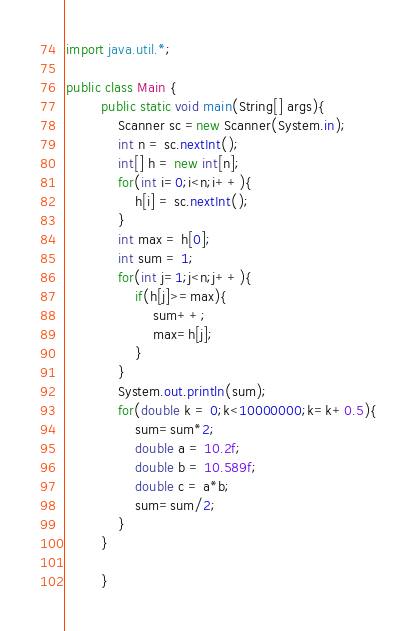<code> <loc_0><loc_0><loc_500><loc_500><_Java_>import java.util.*;

public class Main {
        public static void main(String[] args){
            Scanner sc =new Scanner(System.in);
            int n = sc.nextInt();
            int[] h = new int[n];
            for(int i=0;i<n;i++){
                h[i] = sc.nextInt();
            }
            int max = h[0];
            int sum = 1;
            for(int j=1;j<n;j++){
                if(h[j]>=max){
                    sum++;
                    max=h[j];
                }
            }
            System.out.println(sum);
            for(double k = 0;k<10000000;k=k+0.5){
                sum=sum*2;
                double a = 10.2f;
                double b = 10.589f;
                double c = a*b;
                sum=sum/2;
            }
        }

        }</code> 